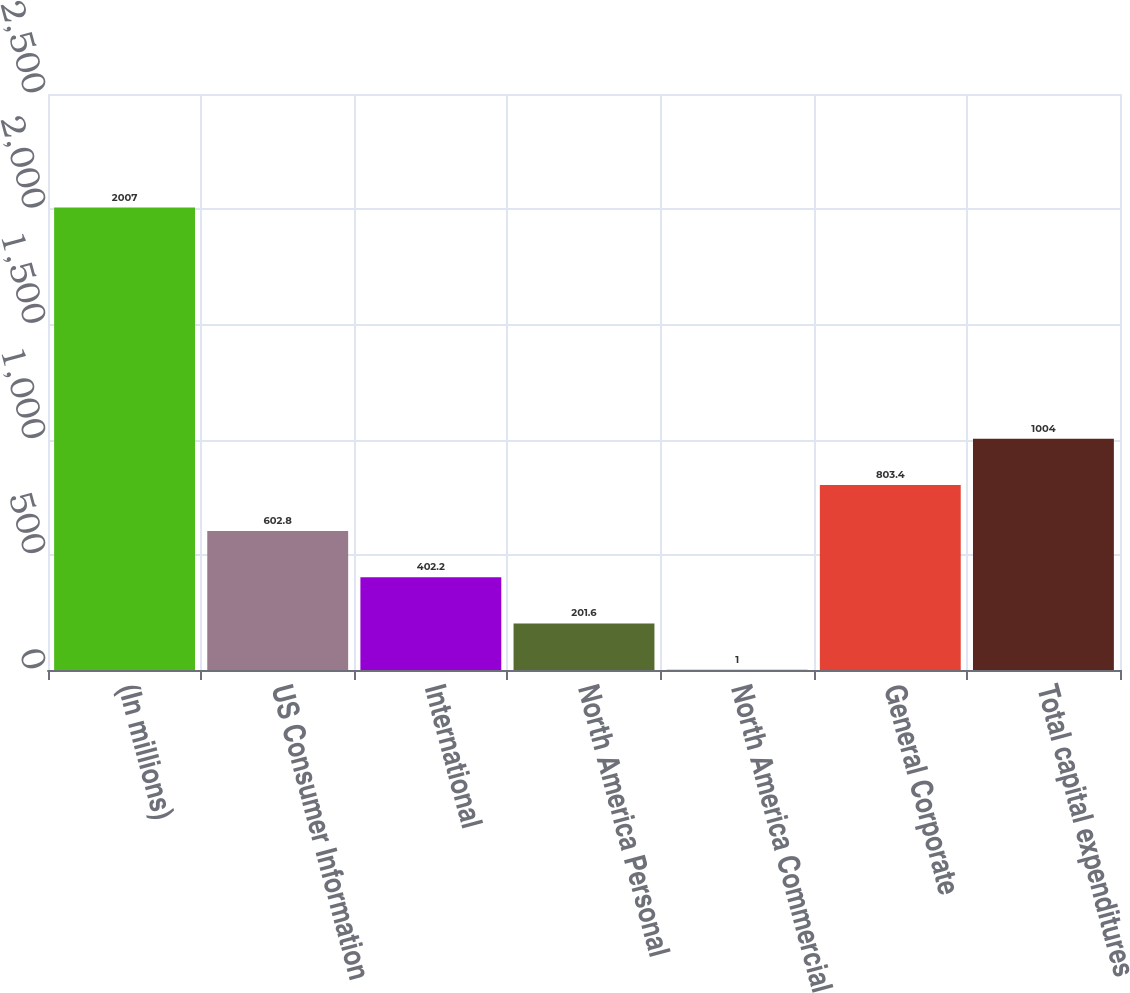<chart> <loc_0><loc_0><loc_500><loc_500><bar_chart><fcel>(In millions)<fcel>US Consumer Information<fcel>International<fcel>North America Personal<fcel>North America Commercial<fcel>General Corporate<fcel>Total capital expenditures<nl><fcel>2007<fcel>602.8<fcel>402.2<fcel>201.6<fcel>1<fcel>803.4<fcel>1004<nl></chart> 